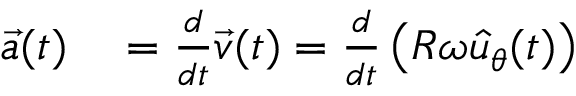Convert formula to latex. <formula><loc_0><loc_0><loc_500><loc_500>\begin{array} { r l } { { \vec { a } } ( t ) } & = { \frac { d } { d t } } { \vec { v } } ( t ) = { \frac { d } { d t } } \left ( R \omega { \hat { u } } _ { \theta } ( t ) \right ) } \end{array}</formula> 